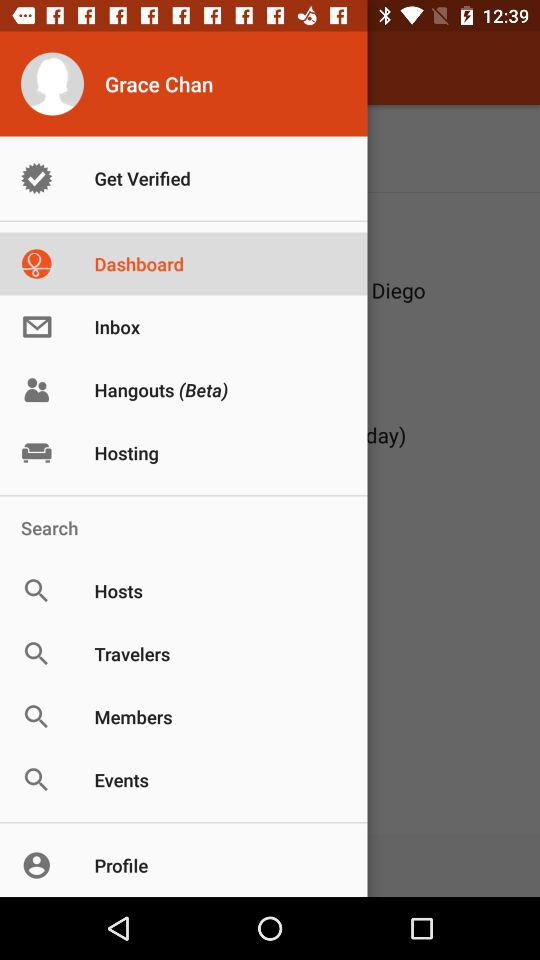What is the login name? The login name is Grace Chan. 